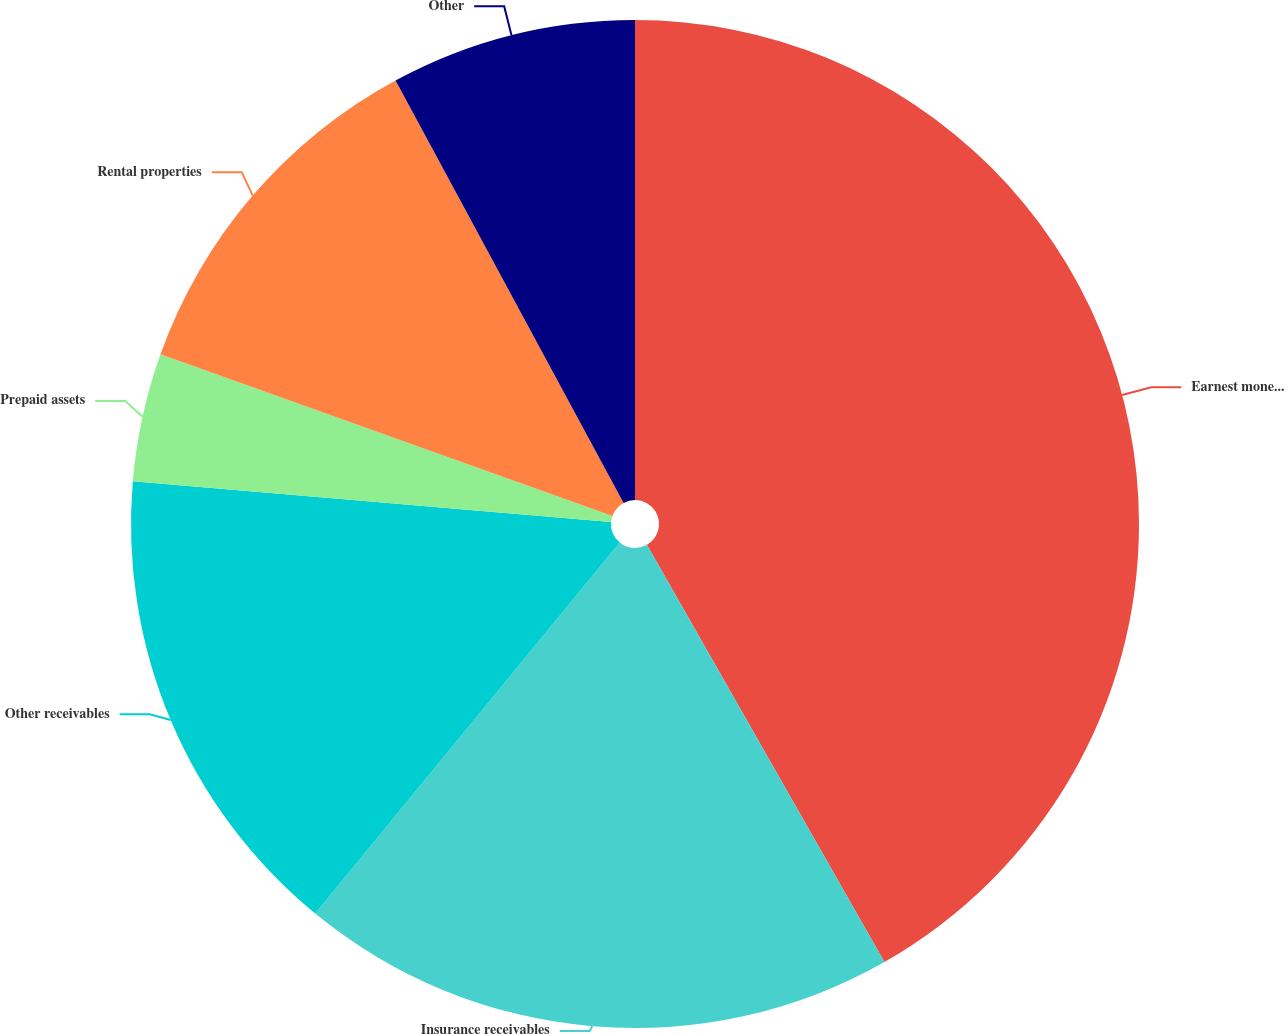Convert chart to OTSL. <chart><loc_0><loc_0><loc_500><loc_500><pie_chart><fcel>Earnest money and refundable<fcel>Insurance receivables<fcel>Other receivables<fcel>Prepaid assets<fcel>Rental properties<fcel>Other<nl><fcel>41.76%<fcel>19.18%<fcel>15.41%<fcel>4.12%<fcel>11.65%<fcel>7.88%<nl></chart> 